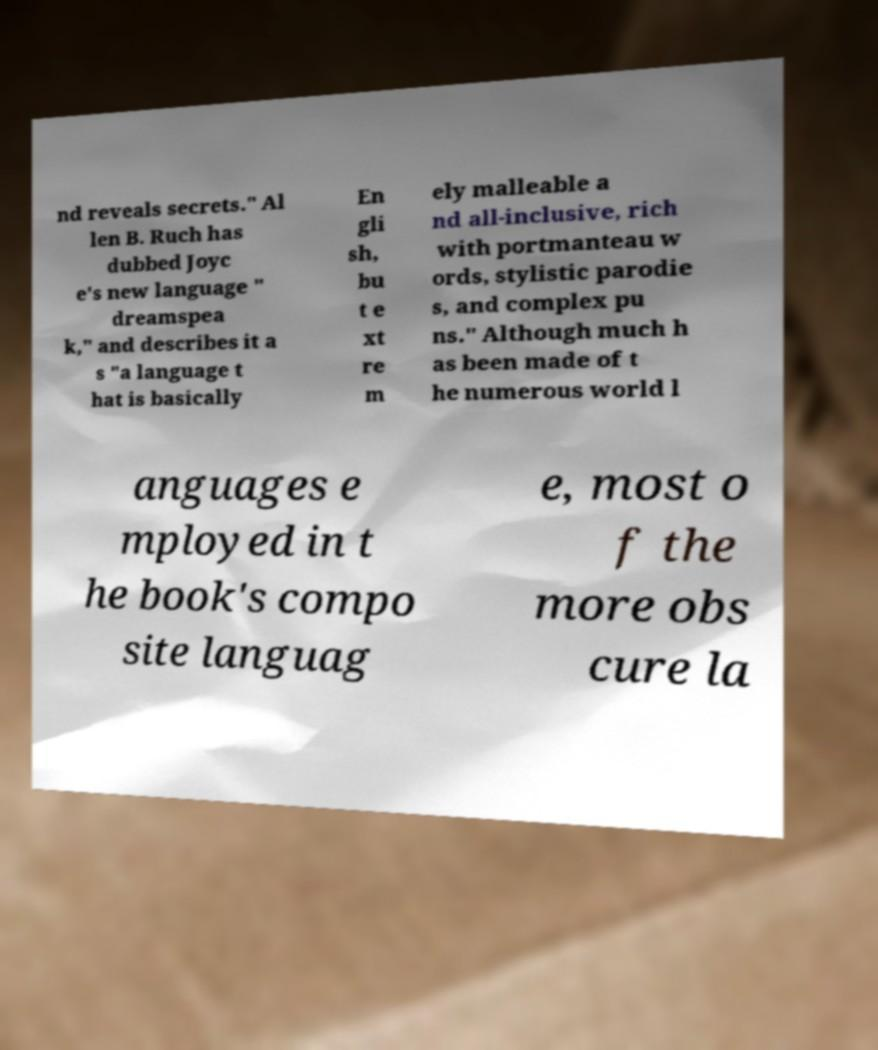What messages or text are displayed in this image? I need them in a readable, typed format. nd reveals secrets." Al len B. Ruch has dubbed Joyc e's new language " dreamspea k," and describes it a s "a language t hat is basically En gli sh, bu t e xt re m ely malleable a nd all-inclusive, rich with portmanteau w ords, stylistic parodie s, and complex pu ns." Although much h as been made of t he numerous world l anguages e mployed in t he book's compo site languag e, most o f the more obs cure la 